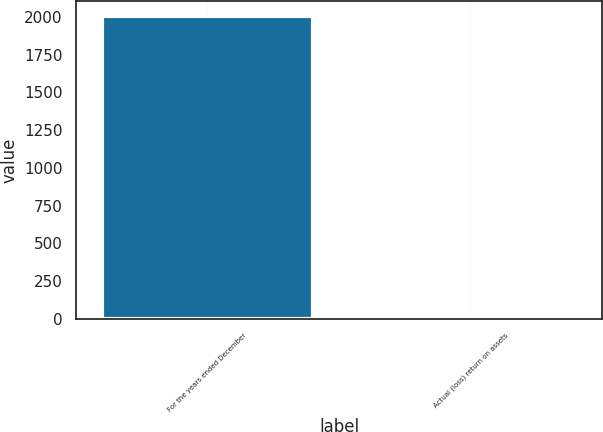<chart> <loc_0><loc_0><loc_500><loc_500><bar_chart><fcel>For the years ended December<fcel>Actual (loss) return on assets<nl><fcel>2006<fcel>15.7<nl></chart> 